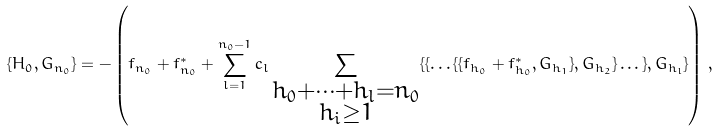Convert formula to latex. <formula><loc_0><loc_0><loc_500><loc_500>\{ H _ { 0 } , G _ { n _ { 0 } } \} = - \left ( f _ { n _ { 0 } } + f _ { n _ { 0 } } ^ { * } + \sum _ { l = 1 } ^ { n _ { 0 } - 1 } c _ { l } \sum _ { \substack { h _ { 0 } + \dots + h _ { l } = n _ { 0 } \\ h _ { i } \geq 1 } } \{ \{ \dots \{ \{ f _ { h _ { 0 } } + f _ { h _ { 0 } } ^ { * } , G _ { h _ { 1 } } \} , G _ { h _ { 2 } } \} \dots \} , G _ { h _ { l } } \} \right ) \, ,</formula> 